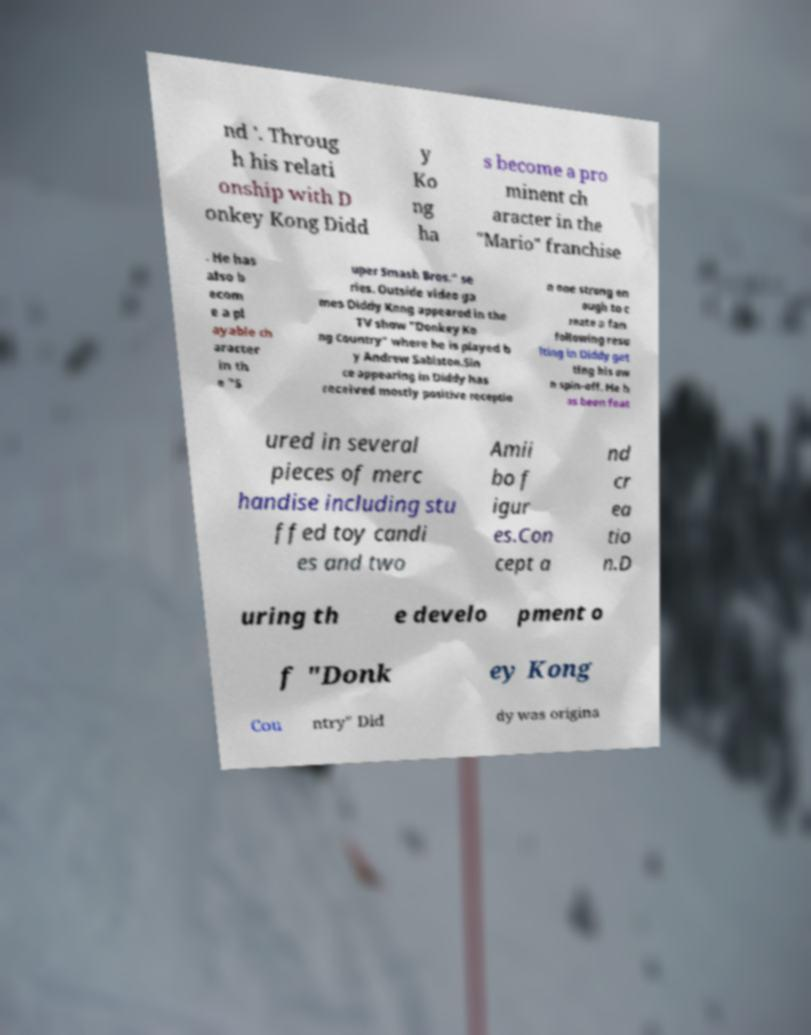Can you read and provide the text displayed in the image?This photo seems to have some interesting text. Can you extract and type it out for me? nd '. Throug h his relati onship with D onkey Kong Didd y Ko ng ha s become a pro minent ch aracter in the "Mario" franchise . He has also b ecom e a pl ayable ch aracter in th e "S uper Smash Bros." se ries. Outside video ga mes Diddy Kong appeared in the TV show "Donkey Ko ng Country" where he is played b y Andrew Sabiston.Sin ce appearing in Diddy has received mostly positive receptio n one strong en ough to c reate a fan following resu lting in Diddy get ting his ow n spin-off. He h as been feat ured in several pieces of merc handise including stu ffed toy candi es and two Amii bo f igur es.Con cept a nd cr ea tio n.D uring th e develo pment o f "Donk ey Kong Cou ntry" Did dy was origina 